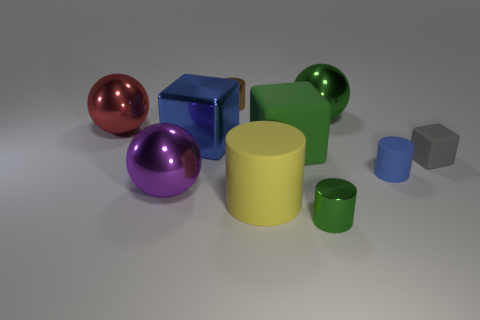Is there any other thing that is the same material as the small gray cube?
Keep it short and to the point. Yes. What shape is the large object that is the same color as the big rubber block?
Give a very brief answer. Sphere. What number of big objects are behind the big rubber cube and in front of the big blue block?
Ensure brevity in your answer.  0. How many other objects are there of the same size as the blue metallic thing?
Ensure brevity in your answer.  5. Is the size of the shiny sphere that is in front of the gray cube the same as the cylinder that is on the left side of the big yellow cylinder?
Your response must be concise. No. How many things are large red cylinders or yellow things that are to the left of the gray block?
Keep it short and to the point. 1. What is the size of the ball that is right of the large blue metal block?
Give a very brief answer. Large. Are there fewer large red shiny things that are in front of the large purple ball than green things that are in front of the red ball?
Provide a succinct answer. Yes. What is the object that is behind the big red ball and in front of the brown metallic thing made of?
Provide a short and direct response. Metal. What is the shape of the blue thing on the left side of the yellow cylinder to the left of the blue matte cylinder?
Your response must be concise. Cube. 